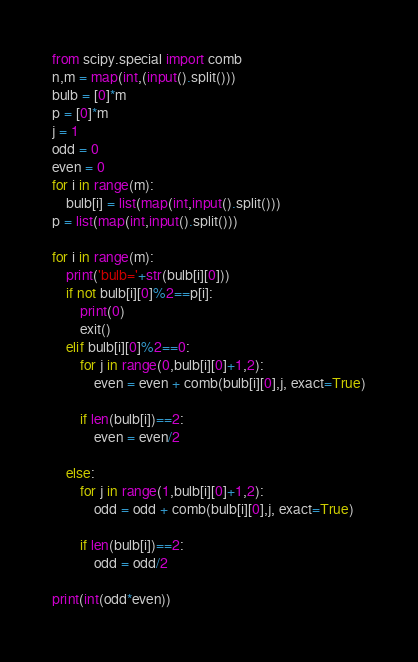<code> <loc_0><loc_0><loc_500><loc_500><_Python_>from scipy.special import comb
n,m = map(int,(input().split()))
bulb = [0]*m
p = [0]*m
j = 1
odd = 0
even = 0
for i in range(m):
    bulb[i] = list(map(int,input().split()))
p = list(map(int,input().split()))

for i in range(m):
    print('bulb='+str(bulb[i][0]))
    if not bulb[i][0]%2==p[i]:
        print(0)
        exit()
    elif bulb[i][0]%2==0:
        for j in range(0,bulb[i][0]+1,2):
            even = even + comb(bulb[i][0],j, exact=True)
            
        if len(bulb[i])==2:
            even = even/2
            
    else:
        for j in range(1,bulb[i][0]+1,2):
            odd = odd + comb(bulb[i][0],j, exact=True)
          
        if len(bulb[i])==2:
            odd = odd/2              

print(int(odd*even))</code> 